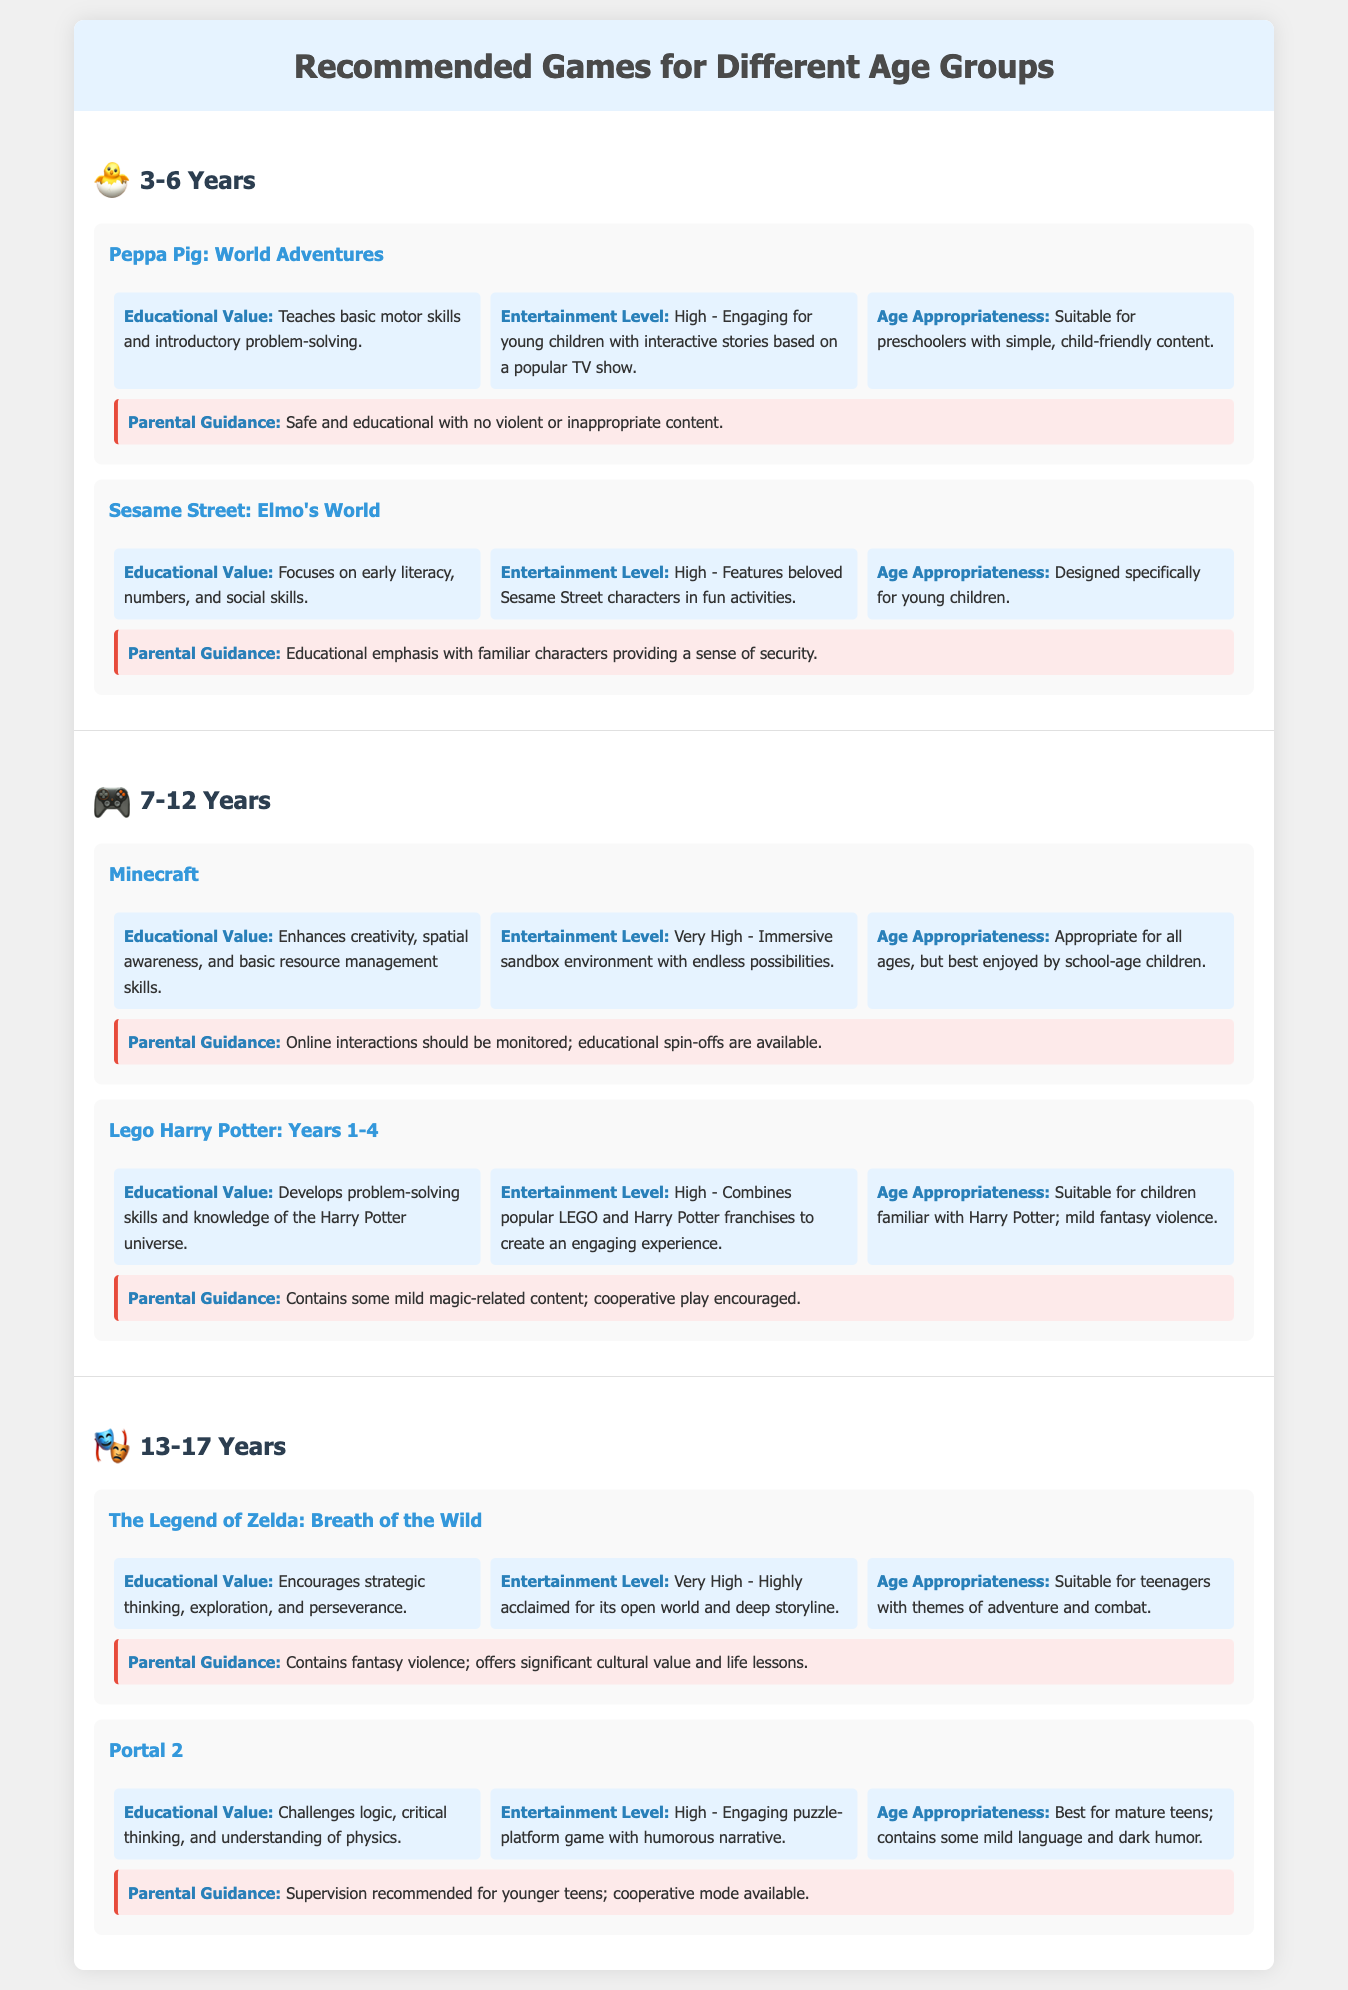What age group is represented by the icon 🐣? The icon 🐣 represents the age group of 3-6 years.
Answer: 3-6 Years What is the entertainment level of Minecraft? Minecraft has a very high entertainment level as stated in the document.
Answer: Very High What educational value does Peppa Pig: World Adventures provide? Peppa Pig: World Adventures teaches basic motor skills and introductory problem-solving.
Answer: Basic motor skills and introductory problem-solving How many games are listed for the age group of 13-17 years? There are two games listed for the age group of 13-17 years in the document.
Answer: Two What type of parental guidance is mentioned for Lego Harry Potter: Years 1-4? The parental guidance states it contains some mild magic-related content; cooperative play encouraged.
Answer: Mild magic-related content; cooperative play encouraged Which game is recommended for its high entertainment value and strategic thinking? The game recommended for high entertainment value and encouraging strategic thinking is The Legend of Zelda: Breath of the Wild.
Answer: The Legend of Zelda: Breath of the Wild What is the focus of educational value for Sesame Street: Elmo's World? The focus of educational value for Sesame Street: Elmo's World is on early literacy, numbers, and social skills.
Answer: Early literacy, numbers, and social skills What is the age appropriateness of Portal 2? The age appropriateness of Portal 2 is best for mature teens.
Answer: Best for mature teens 